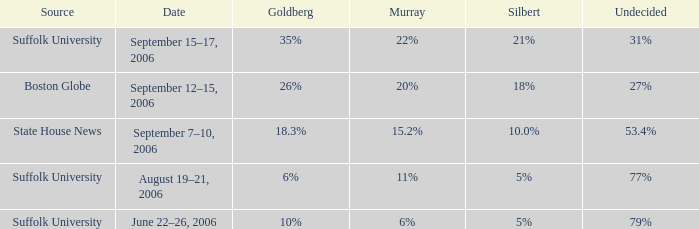What is the date of the poll with Goldberg at 26%? September 12–15, 2006. 